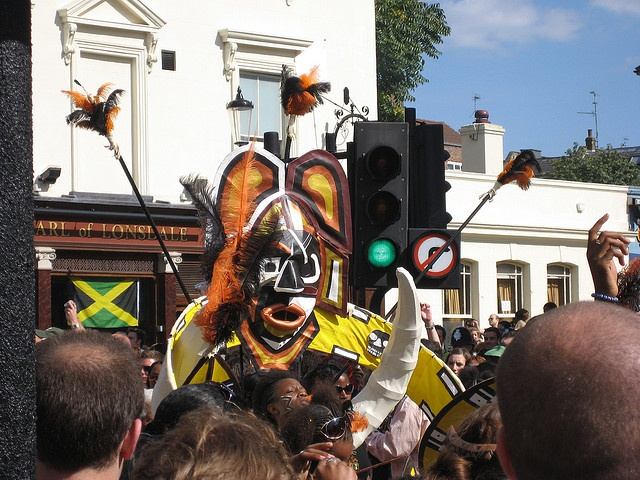Describe the objects in this image and their specific colors. I can see people in black, maroon, gray, and brown tones, people in black, maroon, and gray tones, people in black, maroon, and gray tones, traffic light in black, gray, and teal tones, and people in black, maroon, and brown tones in this image. 